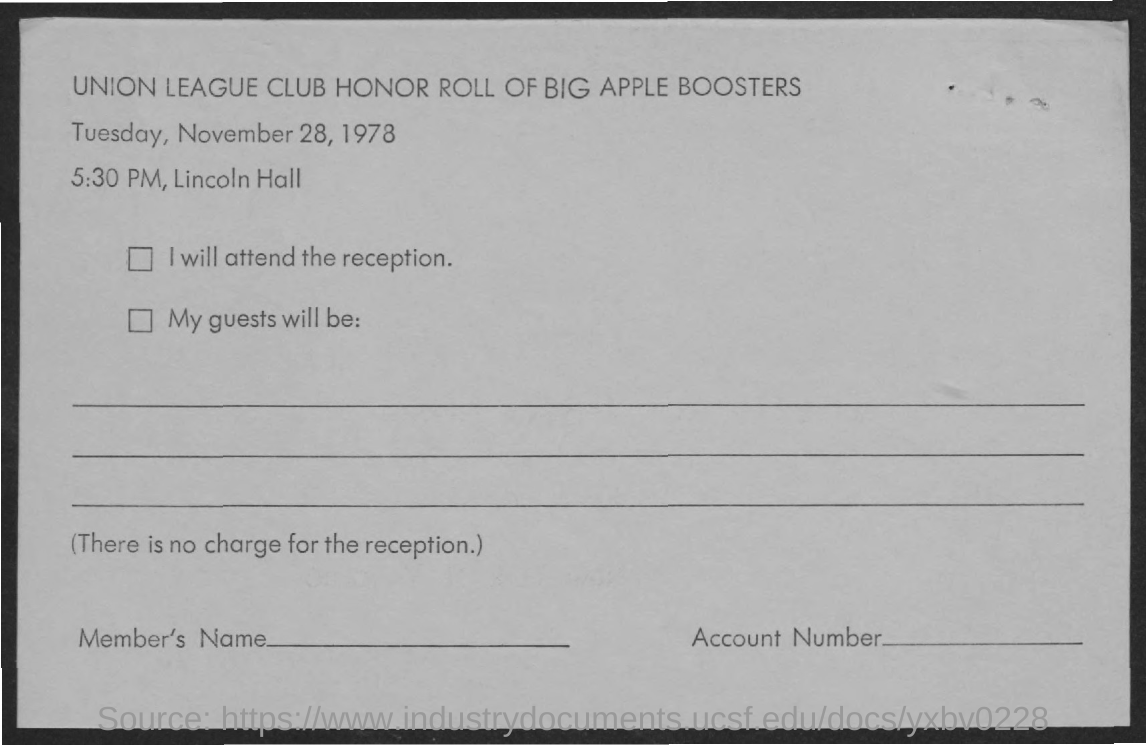Give some essential details in this illustration. The Union League Club Honor Roll of Big Apple Boosters is located in Lincoln Hall. The Union League Club Honor Roll of Big Apple Boosters will take place on Tuesday, November 28, 1978. 